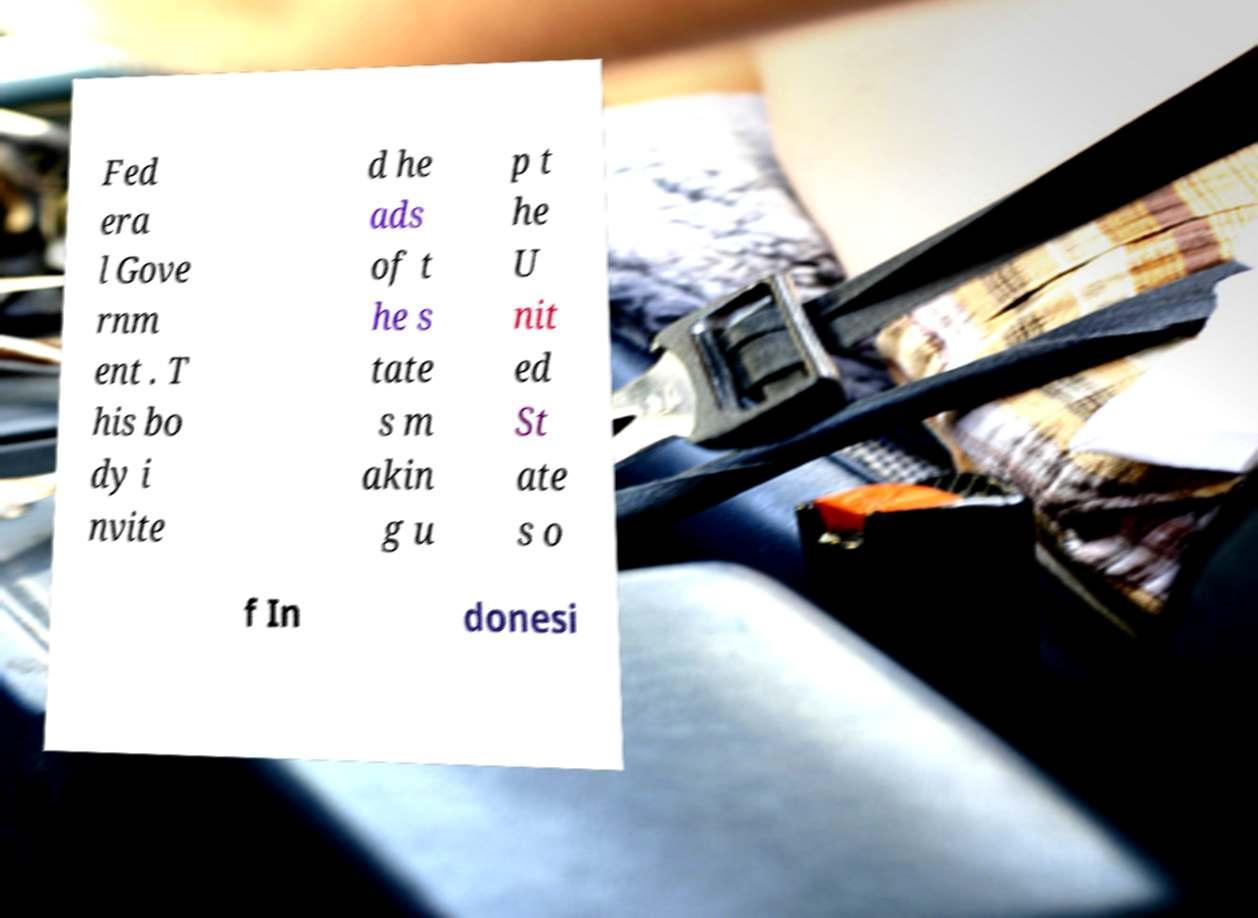There's text embedded in this image that I need extracted. Can you transcribe it verbatim? Fed era l Gove rnm ent . T his bo dy i nvite d he ads of t he s tate s m akin g u p t he U nit ed St ate s o f In donesi 